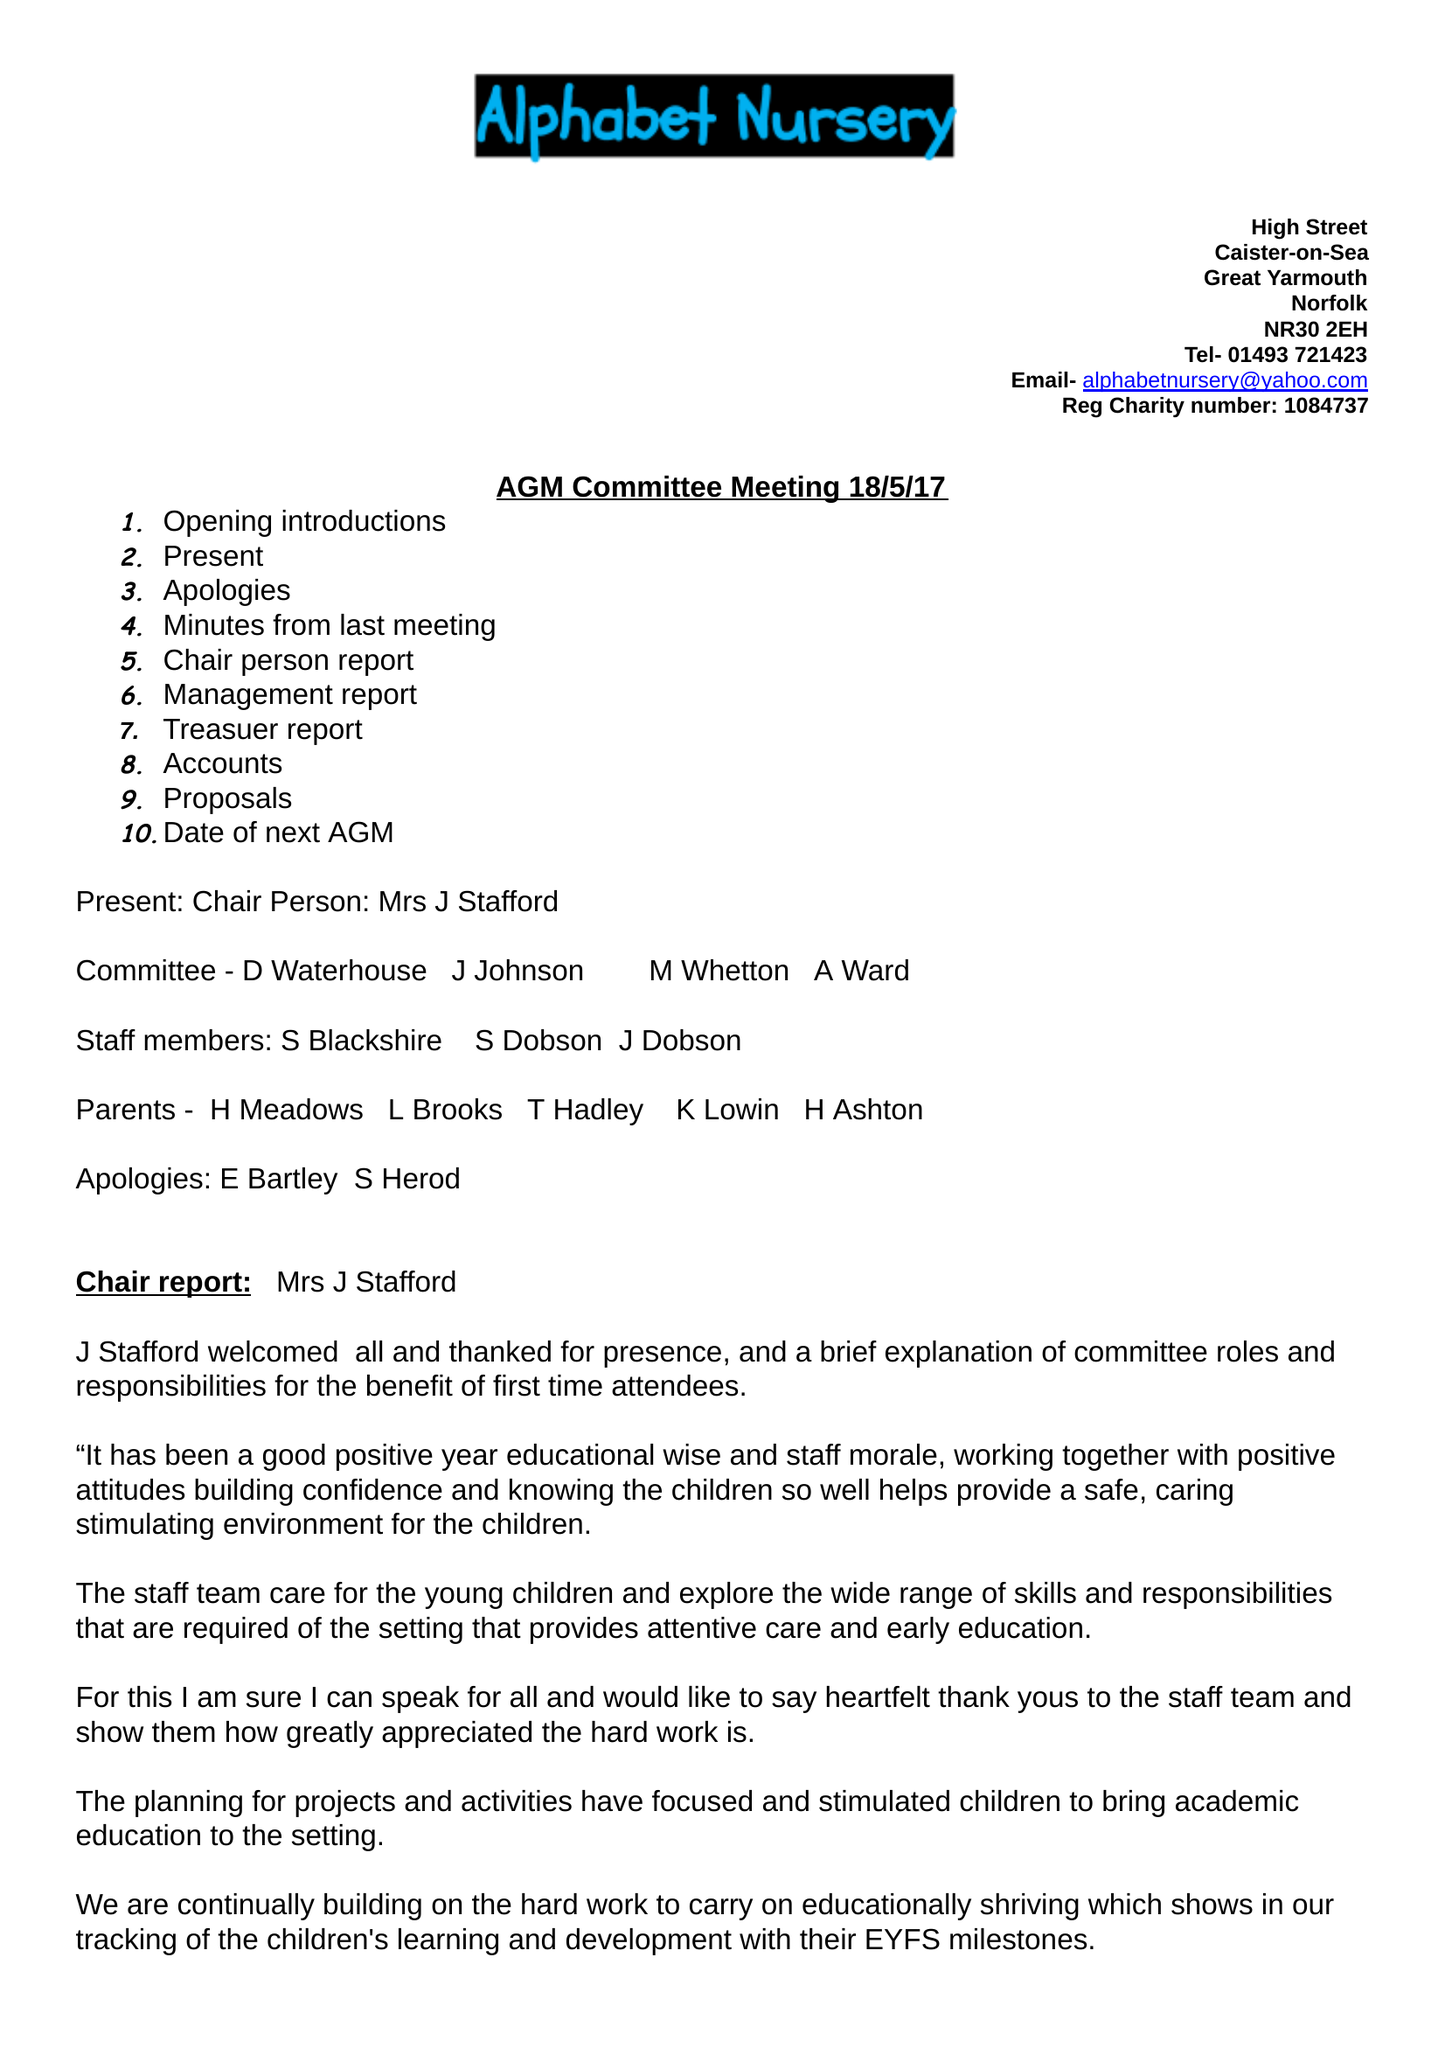What is the value for the address__street_line?
Answer the question using a single word or phrase. None 